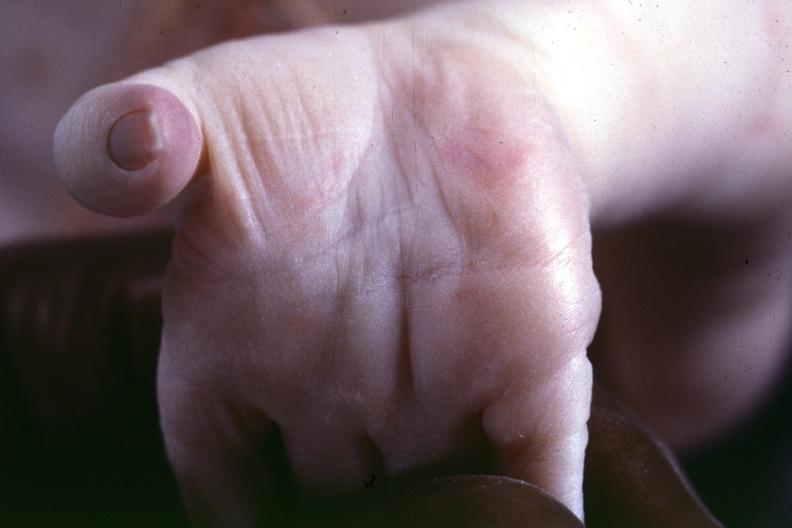s embryo-fetus present?
Answer the question using a single word or phrase. No 